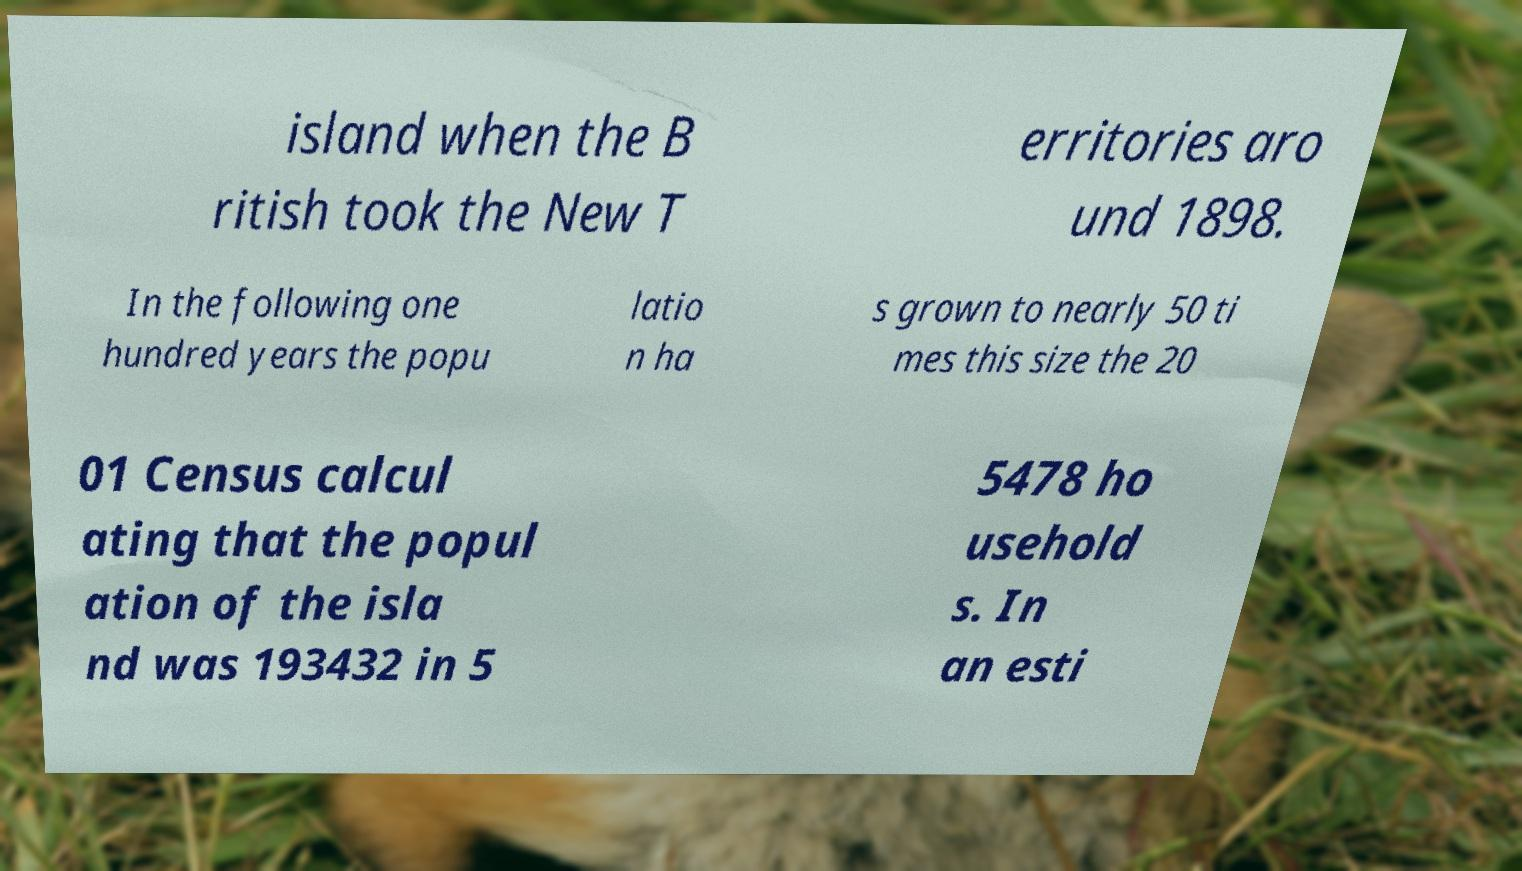Please read and relay the text visible in this image. What does it say? island when the B ritish took the New T erritories aro und 1898. In the following one hundred years the popu latio n ha s grown to nearly 50 ti mes this size the 20 01 Census calcul ating that the popul ation of the isla nd was 193432 in 5 5478 ho usehold s. In an esti 